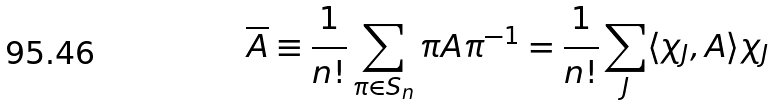Convert formula to latex. <formula><loc_0><loc_0><loc_500><loc_500>\overline { A } \equiv \frac { 1 } { n ! } \sum _ { \pi \in S _ { n } } \pi A \pi ^ { - 1 } = \frac { 1 } { n ! } \sum _ { J } \langle \chi _ { J } , A \rangle \chi _ { J }</formula> 